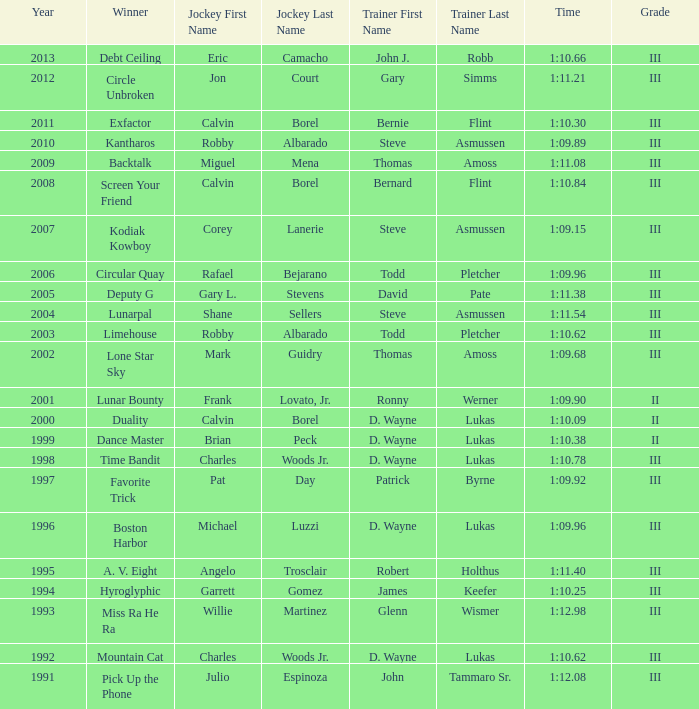Who won under Gary Simms? Circle Unbroken. 